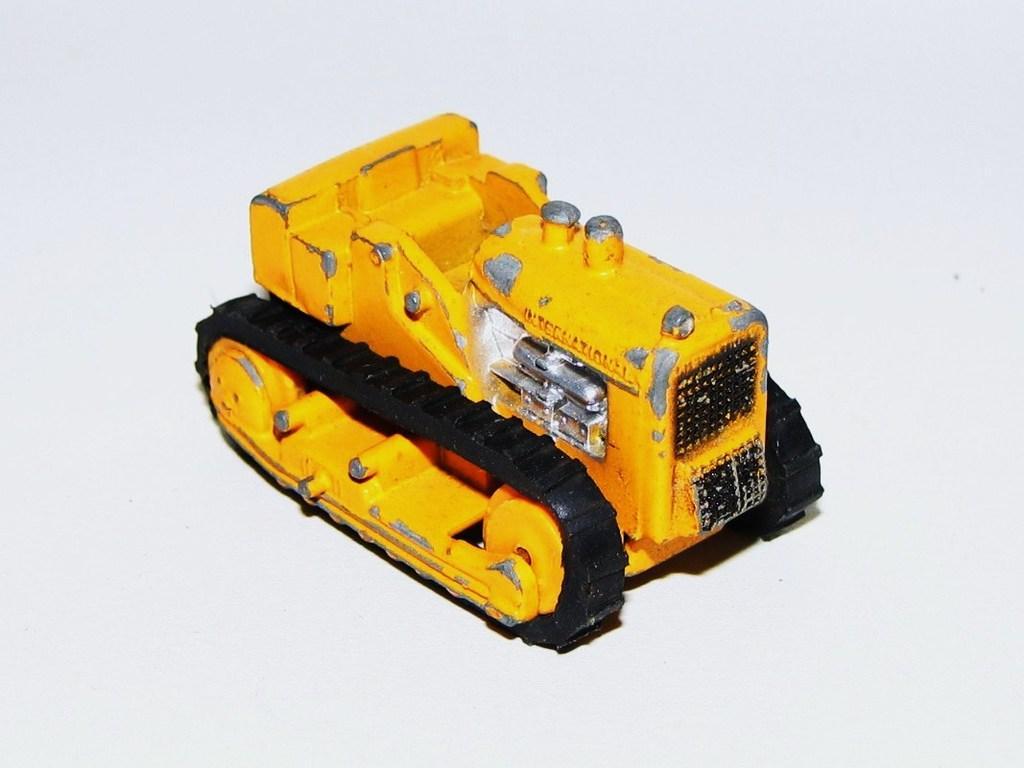Can you describe this image briefly? In this picture there is a toy vehicle. At the back there is a white background. 